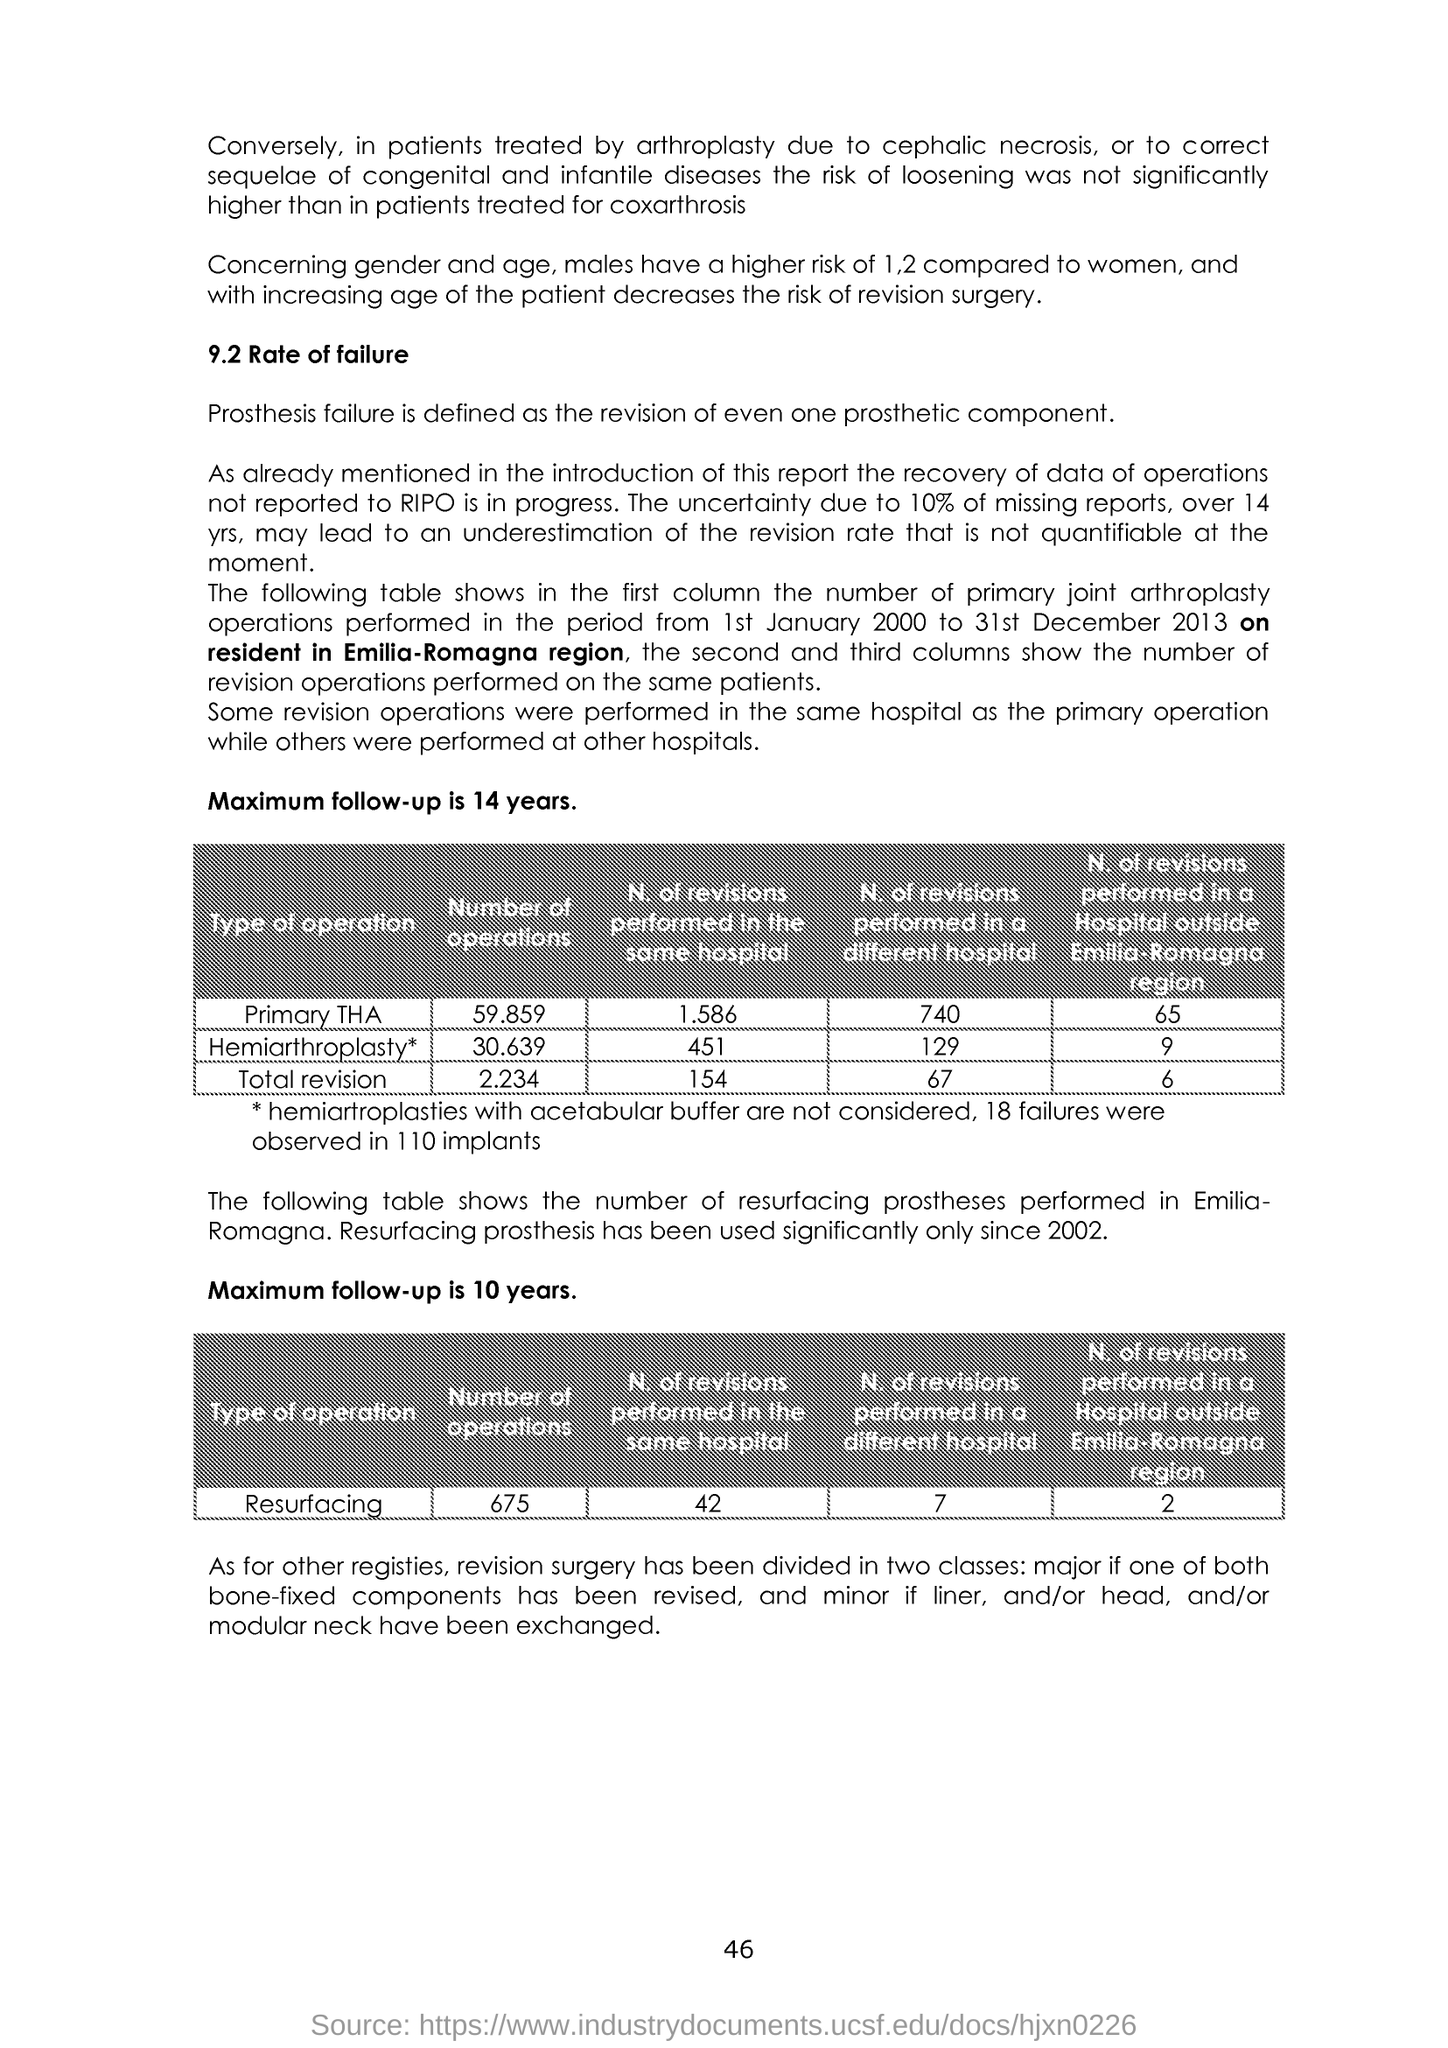What is the Page Number?
Your response must be concise. 46. 